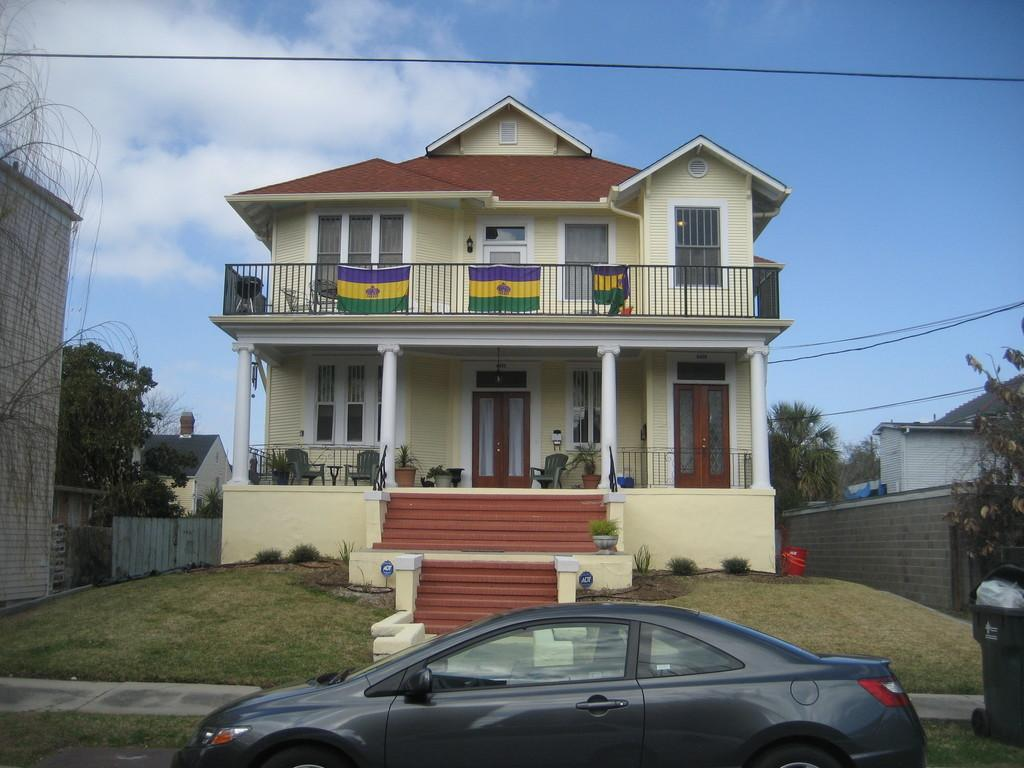What type of structures are visible in the image? There are buildings with windows, doors, and pillars in the image. What can be found near the buildings? There are plants in pots, stairs, trees, and weirs visible in the image. What is the ground like in the image? The ground with grass is visible in the image. What else can be seen in the image? There is a road, vehicles, and the sky with clouds are present in the image. Can you see the ocean in the image? No, the ocean is not present in the image. Where would you find the lunchroom in the image? There is no mention of a lunchroom in the image, so it cannot be located. 